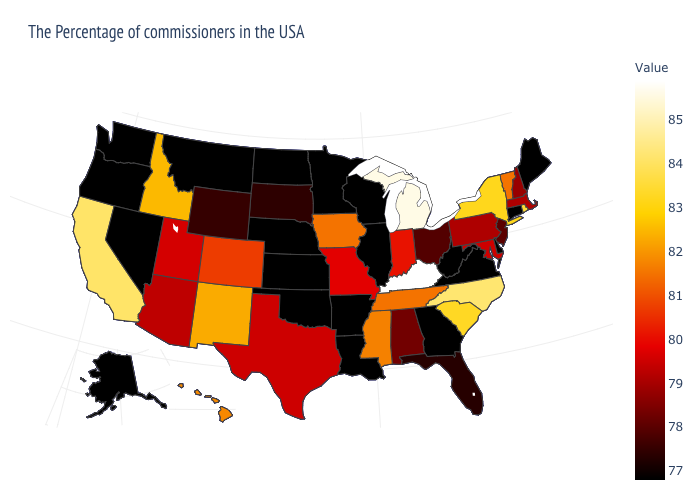Which states hav the highest value in the Northeast?
Keep it brief. Rhode Island. Which states hav the highest value in the MidWest?
Write a very short answer. Michigan. Among the states that border Rhode Island , does Massachusetts have the highest value?
Keep it brief. Yes. Which states have the lowest value in the USA?
Write a very short answer. Maine, Connecticut, Delaware, Virginia, West Virginia, Georgia, Wisconsin, Illinois, Louisiana, Arkansas, Minnesota, Kansas, Nebraska, Oklahoma, North Dakota, Montana, Nevada, Washington, Oregon, Alaska. Which states have the lowest value in the MidWest?
Be succinct. Wisconsin, Illinois, Minnesota, Kansas, Nebraska, North Dakota. Which states have the lowest value in the MidWest?
Quick response, please. Wisconsin, Illinois, Minnesota, Kansas, Nebraska, North Dakota. 